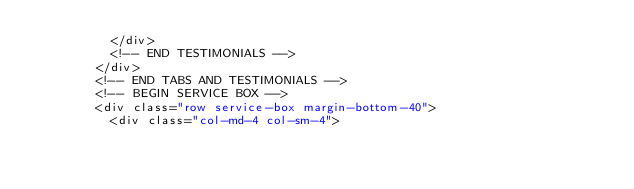<code> <loc_0><loc_0><loc_500><loc_500><_PHP_>          </div>
          <!-- END TESTIMONIALS -->
        </div>                
        <!-- END TABS AND TESTIMONIALS -->
        <!-- BEGIN SERVICE BOX -->   
        <div class="row service-box margin-bottom-40">
          <div class="col-md-4 col-sm-4"></code> 